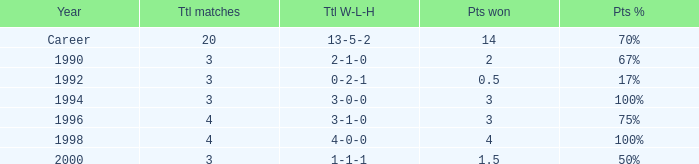Can you tell me the lowest Total natches that has the Points won of 3, and the Year of 1994? 3.0. Would you mind parsing the complete table? {'header': ['Year', 'Ttl matches', 'Ttl W-L-H', 'Pts won', 'Pts %'], 'rows': [['Career', '20', '13-5-2', '14', '70%'], ['1990', '3', '2-1-0', '2', '67%'], ['1992', '3', '0-2-1', '0.5', '17%'], ['1994', '3', '3-0-0', '3', '100%'], ['1996', '4', '3-1-0', '3', '75%'], ['1998', '4', '4-0-0', '4', '100%'], ['2000', '3', '1-1-1', '1.5', '50%']]} 